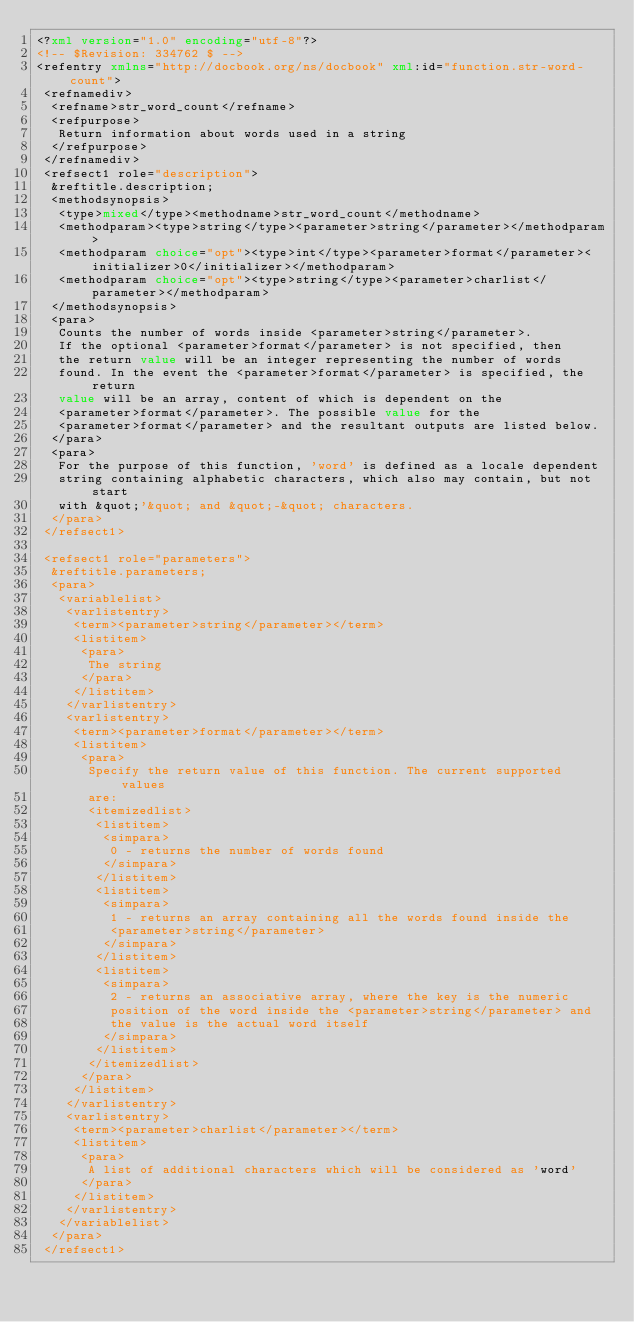<code> <loc_0><loc_0><loc_500><loc_500><_XML_><?xml version="1.0" encoding="utf-8"?>
<!-- $Revision: 334762 $ -->
<refentry xmlns="http://docbook.org/ns/docbook" xml:id="function.str-word-count">
 <refnamediv>
  <refname>str_word_count</refname>
  <refpurpose>
   Return information about words used in a string
  </refpurpose>
 </refnamediv>
 <refsect1 role="description">
  &reftitle.description;
  <methodsynopsis>
   <type>mixed</type><methodname>str_word_count</methodname>
   <methodparam><type>string</type><parameter>string</parameter></methodparam>
   <methodparam choice="opt"><type>int</type><parameter>format</parameter><initializer>0</initializer></methodparam>
   <methodparam choice="opt"><type>string</type><parameter>charlist</parameter></methodparam>
  </methodsynopsis>
  <para>
   Counts the number of words inside <parameter>string</parameter>. 
   If the optional <parameter>format</parameter> is not specified, then 
   the return value will be an integer representing the number of words 
   found. In the event the <parameter>format</parameter> is specified, the return
   value will be an array, content of which is dependent on the 
   <parameter>format</parameter>. The possible value for the 
   <parameter>format</parameter> and the resultant outputs are listed below.
  </para>
  <para>
   For the purpose of this function, 'word' is defined as a locale dependent
   string containing alphabetic characters, which also may contain, but not start
   with &quot;'&quot; and &quot;-&quot; characters.
  </para>
 </refsect1>

 <refsect1 role="parameters">
  &reftitle.parameters;
  <para>
   <variablelist>
    <varlistentry>
     <term><parameter>string</parameter></term>
     <listitem>
      <para>
       The string
      </para>
     </listitem>
    </varlistentry>
    <varlistentry>
     <term><parameter>format</parameter></term>
     <listitem>
      <para>
       Specify the return value of this function. The current supported values
       are:
       <itemizedlist>
        <listitem>
         <simpara>
          0 - returns the number of words found
         </simpara>
        </listitem>
        <listitem>
         <simpara>
          1 - returns an array containing all the words found inside the
          <parameter>string</parameter>
         </simpara>
        </listitem>
        <listitem>
         <simpara>
          2 - returns an associative array, where the key is the numeric
          position of the word inside the <parameter>string</parameter> and
          the value is the actual word itself
         </simpara>
        </listitem> 
       </itemizedlist>
      </para>
     </listitem>
    </varlistentry>
    <varlistentry>
     <term><parameter>charlist</parameter></term>
     <listitem>
      <para>
       A list of additional characters which will be considered as 'word'
      </para>
     </listitem>
    </varlistentry>
   </variablelist>
  </para>
 </refsect1>
</code> 